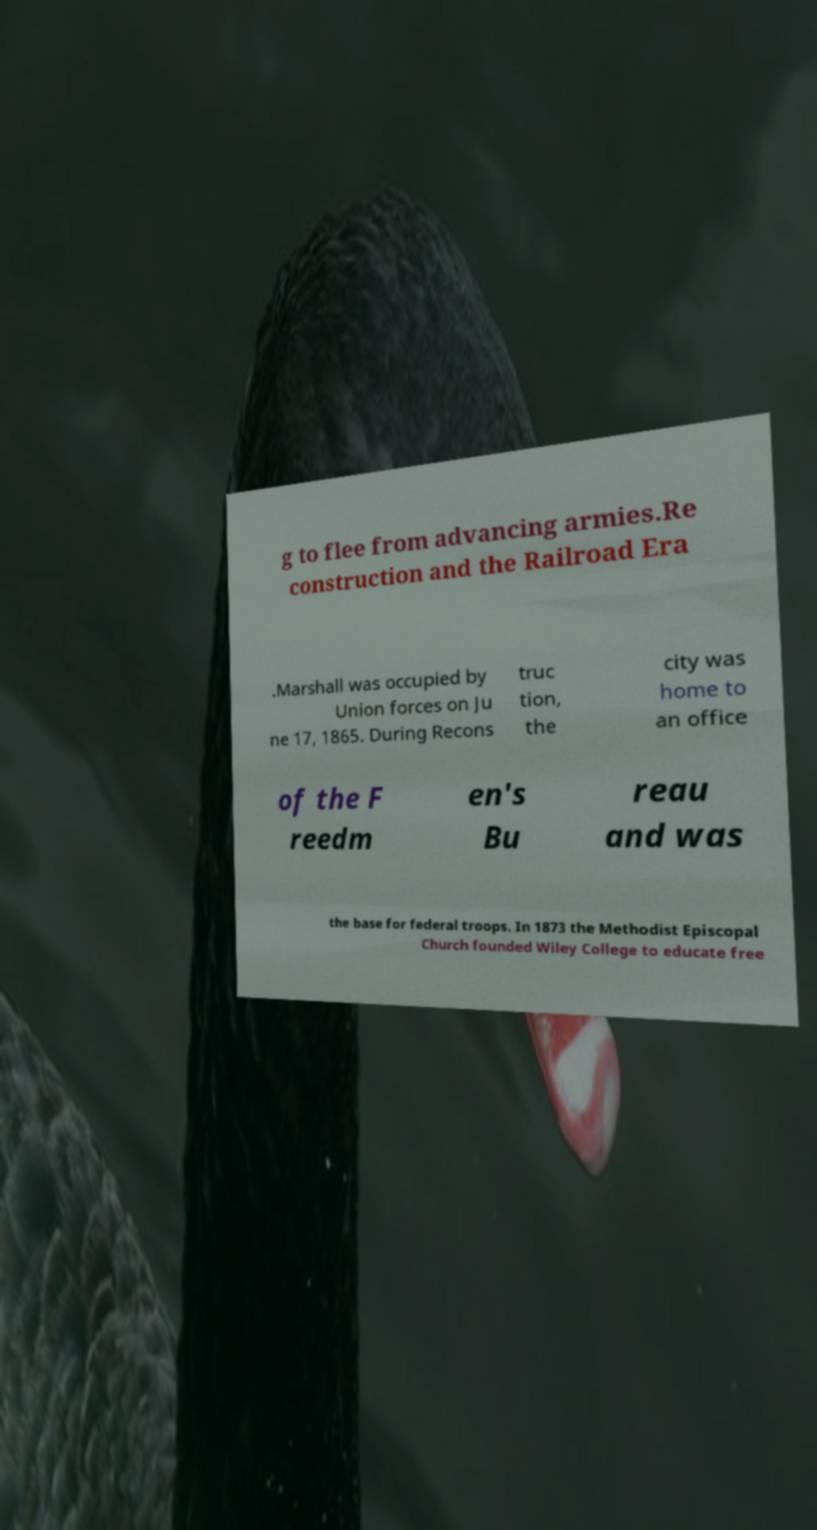Could you extract and type out the text from this image? g to flee from advancing armies.Re construction and the Railroad Era .Marshall was occupied by Union forces on Ju ne 17, 1865. During Recons truc tion, the city was home to an office of the F reedm en's Bu reau and was the base for federal troops. In 1873 the Methodist Episcopal Church founded Wiley College to educate free 